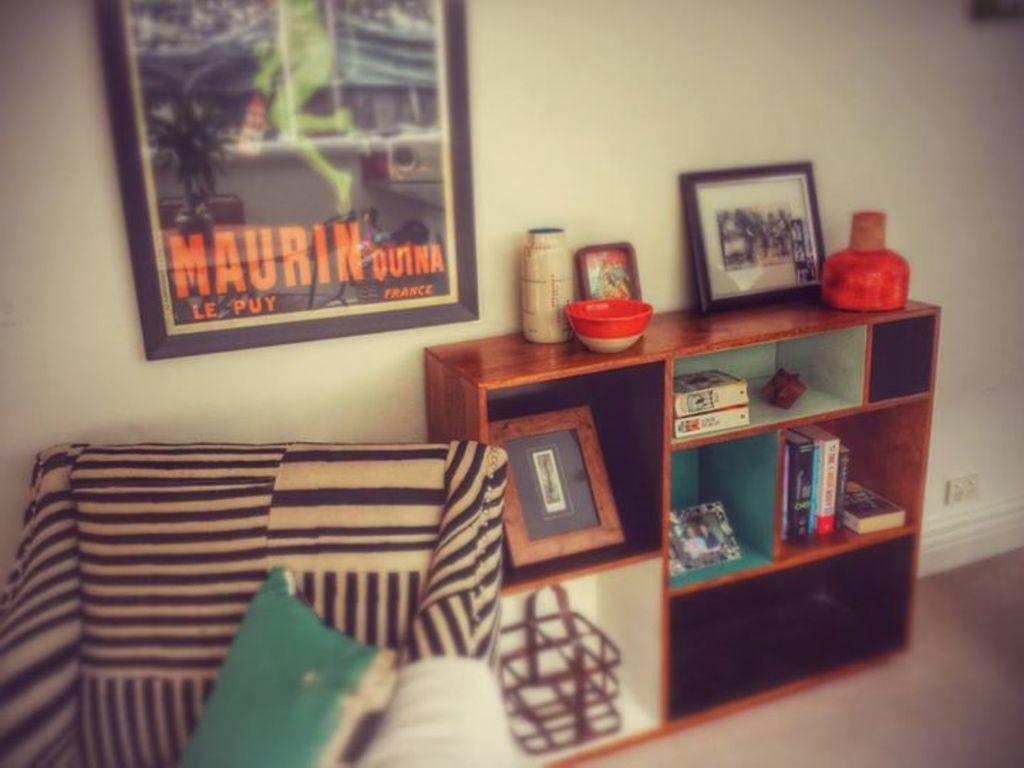<image>
Write a terse but informative summary of the picture. A living room with a Maurin Outna picture from France. 